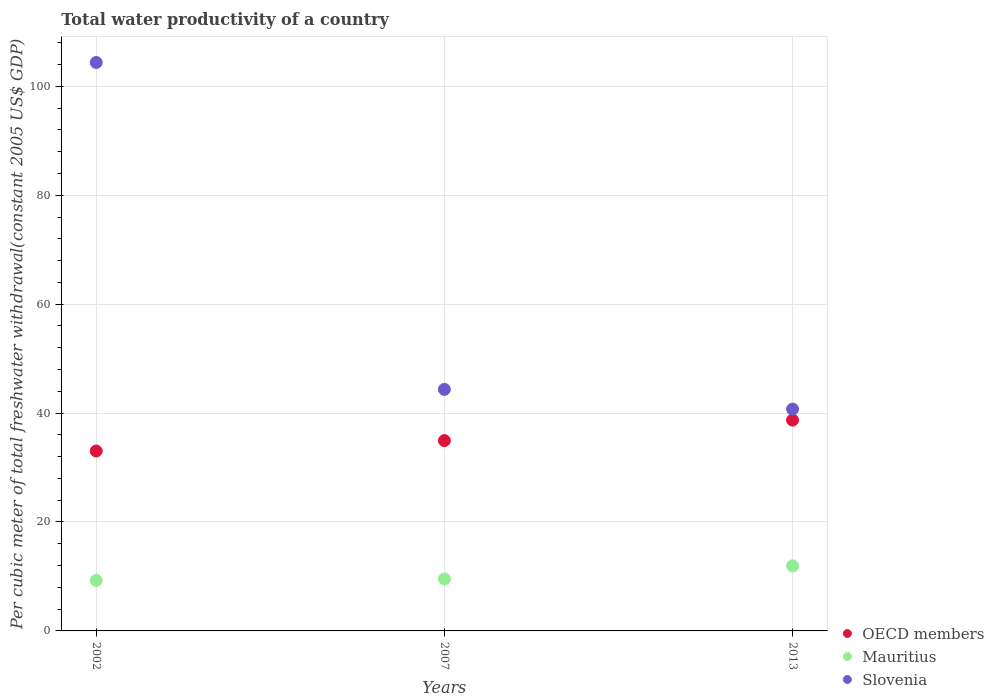What is the total water productivity in Slovenia in 2002?
Provide a short and direct response. 104.38. Across all years, what is the maximum total water productivity in Slovenia?
Offer a terse response. 104.38. Across all years, what is the minimum total water productivity in OECD members?
Your answer should be compact. 33.04. What is the total total water productivity in Slovenia in the graph?
Give a very brief answer. 189.45. What is the difference between the total water productivity in Mauritius in 2007 and that in 2013?
Make the answer very short. -2.41. What is the difference between the total water productivity in Mauritius in 2002 and the total water productivity in Slovenia in 2013?
Offer a very short reply. -31.44. What is the average total water productivity in Slovenia per year?
Your answer should be compact. 63.15. In the year 2013, what is the difference between the total water productivity in OECD members and total water productivity in Mauritius?
Provide a succinct answer. 26.76. In how many years, is the total water productivity in Mauritius greater than 28 US$?
Offer a terse response. 0. What is the ratio of the total water productivity in Slovenia in 2002 to that in 2013?
Ensure brevity in your answer.  2.56. Is the total water productivity in Slovenia in 2002 less than that in 2013?
Your answer should be very brief. No. What is the difference between the highest and the second highest total water productivity in Slovenia?
Offer a terse response. 60.02. What is the difference between the highest and the lowest total water productivity in OECD members?
Keep it short and to the point. 5.68. Is the sum of the total water productivity in Slovenia in 2002 and 2007 greater than the maximum total water productivity in Mauritius across all years?
Ensure brevity in your answer.  Yes. Is it the case that in every year, the sum of the total water productivity in Mauritius and total water productivity in OECD members  is greater than the total water productivity in Slovenia?
Offer a very short reply. No. Does the total water productivity in OECD members monotonically increase over the years?
Your response must be concise. Yes. Is the total water productivity in Slovenia strictly less than the total water productivity in Mauritius over the years?
Offer a terse response. No. Are the values on the major ticks of Y-axis written in scientific E-notation?
Provide a succinct answer. No. Does the graph contain grids?
Offer a very short reply. Yes. What is the title of the graph?
Give a very brief answer. Total water productivity of a country. Does "Monaco" appear as one of the legend labels in the graph?
Your answer should be very brief. No. What is the label or title of the X-axis?
Keep it short and to the point. Years. What is the label or title of the Y-axis?
Your response must be concise. Per cubic meter of total freshwater withdrawal(constant 2005 US$ GDP). What is the Per cubic meter of total freshwater withdrawal(constant 2005 US$ GDP) in OECD members in 2002?
Your response must be concise. 33.04. What is the Per cubic meter of total freshwater withdrawal(constant 2005 US$ GDP) in Mauritius in 2002?
Provide a succinct answer. 9.28. What is the Per cubic meter of total freshwater withdrawal(constant 2005 US$ GDP) in Slovenia in 2002?
Ensure brevity in your answer.  104.38. What is the Per cubic meter of total freshwater withdrawal(constant 2005 US$ GDP) of OECD members in 2007?
Your response must be concise. 34.94. What is the Per cubic meter of total freshwater withdrawal(constant 2005 US$ GDP) of Mauritius in 2007?
Provide a succinct answer. 9.54. What is the Per cubic meter of total freshwater withdrawal(constant 2005 US$ GDP) in Slovenia in 2007?
Offer a terse response. 44.35. What is the Per cubic meter of total freshwater withdrawal(constant 2005 US$ GDP) of OECD members in 2013?
Offer a very short reply. 38.71. What is the Per cubic meter of total freshwater withdrawal(constant 2005 US$ GDP) of Mauritius in 2013?
Provide a succinct answer. 11.95. What is the Per cubic meter of total freshwater withdrawal(constant 2005 US$ GDP) of Slovenia in 2013?
Give a very brief answer. 40.73. Across all years, what is the maximum Per cubic meter of total freshwater withdrawal(constant 2005 US$ GDP) in OECD members?
Your answer should be compact. 38.71. Across all years, what is the maximum Per cubic meter of total freshwater withdrawal(constant 2005 US$ GDP) in Mauritius?
Keep it short and to the point. 11.95. Across all years, what is the maximum Per cubic meter of total freshwater withdrawal(constant 2005 US$ GDP) of Slovenia?
Provide a short and direct response. 104.38. Across all years, what is the minimum Per cubic meter of total freshwater withdrawal(constant 2005 US$ GDP) of OECD members?
Your response must be concise. 33.04. Across all years, what is the minimum Per cubic meter of total freshwater withdrawal(constant 2005 US$ GDP) in Mauritius?
Your response must be concise. 9.28. Across all years, what is the minimum Per cubic meter of total freshwater withdrawal(constant 2005 US$ GDP) in Slovenia?
Keep it short and to the point. 40.73. What is the total Per cubic meter of total freshwater withdrawal(constant 2005 US$ GDP) in OECD members in the graph?
Your answer should be very brief. 106.69. What is the total Per cubic meter of total freshwater withdrawal(constant 2005 US$ GDP) in Mauritius in the graph?
Provide a short and direct response. 30.77. What is the total Per cubic meter of total freshwater withdrawal(constant 2005 US$ GDP) of Slovenia in the graph?
Ensure brevity in your answer.  189.45. What is the difference between the Per cubic meter of total freshwater withdrawal(constant 2005 US$ GDP) of OECD members in 2002 and that in 2007?
Ensure brevity in your answer.  -1.91. What is the difference between the Per cubic meter of total freshwater withdrawal(constant 2005 US$ GDP) in Mauritius in 2002 and that in 2007?
Offer a very short reply. -0.26. What is the difference between the Per cubic meter of total freshwater withdrawal(constant 2005 US$ GDP) in Slovenia in 2002 and that in 2007?
Your answer should be very brief. 60.02. What is the difference between the Per cubic meter of total freshwater withdrawal(constant 2005 US$ GDP) in OECD members in 2002 and that in 2013?
Ensure brevity in your answer.  -5.68. What is the difference between the Per cubic meter of total freshwater withdrawal(constant 2005 US$ GDP) in Mauritius in 2002 and that in 2013?
Give a very brief answer. -2.66. What is the difference between the Per cubic meter of total freshwater withdrawal(constant 2005 US$ GDP) in Slovenia in 2002 and that in 2013?
Offer a terse response. 63.65. What is the difference between the Per cubic meter of total freshwater withdrawal(constant 2005 US$ GDP) of OECD members in 2007 and that in 2013?
Give a very brief answer. -3.77. What is the difference between the Per cubic meter of total freshwater withdrawal(constant 2005 US$ GDP) in Mauritius in 2007 and that in 2013?
Offer a terse response. -2.41. What is the difference between the Per cubic meter of total freshwater withdrawal(constant 2005 US$ GDP) of Slovenia in 2007 and that in 2013?
Provide a short and direct response. 3.62. What is the difference between the Per cubic meter of total freshwater withdrawal(constant 2005 US$ GDP) of OECD members in 2002 and the Per cubic meter of total freshwater withdrawal(constant 2005 US$ GDP) of Mauritius in 2007?
Keep it short and to the point. 23.5. What is the difference between the Per cubic meter of total freshwater withdrawal(constant 2005 US$ GDP) of OECD members in 2002 and the Per cubic meter of total freshwater withdrawal(constant 2005 US$ GDP) of Slovenia in 2007?
Keep it short and to the point. -11.31. What is the difference between the Per cubic meter of total freshwater withdrawal(constant 2005 US$ GDP) in Mauritius in 2002 and the Per cubic meter of total freshwater withdrawal(constant 2005 US$ GDP) in Slovenia in 2007?
Provide a succinct answer. -35.07. What is the difference between the Per cubic meter of total freshwater withdrawal(constant 2005 US$ GDP) in OECD members in 2002 and the Per cubic meter of total freshwater withdrawal(constant 2005 US$ GDP) in Mauritius in 2013?
Make the answer very short. 21.09. What is the difference between the Per cubic meter of total freshwater withdrawal(constant 2005 US$ GDP) of OECD members in 2002 and the Per cubic meter of total freshwater withdrawal(constant 2005 US$ GDP) of Slovenia in 2013?
Make the answer very short. -7.69. What is the difference between the Per cubic meter of total freshwater withdrawal(constant 2005 US$ GDP) in Mauritius in 2002 and the Per cubic meter of total freshwater withdrawal(constant 2005 US$ GDP) in Slovenia in 2013?
Ensure brevity in your answer.  -31.44. What is the difference between the Per cubic meter of total freshwater withdrawal(constant 2005 US$ GDP) in OECD members in 2007 and the Per cubic meter of total freshwater withdrawal(constant 2005 US$ GDP) in Mauritius in 2013?
Offer a very short reply. 23. What is the difference between the Per cubic meter of total freshwater withdrawal(constant 2005 US$ GDP) in OECD members in 2007 and the Per cubic meter of total freshwater withdrawal(constant 2005 US$ GDP) in Slovenia in 2013?
Your response must be concise. -5.78. What is the difference between the Per cubic meter of total freshwater withdrawal(constant 2005 US$ GDP) in Mauritius in 2007 and the Per cubic meter of total freshwater withdrawal(constant 2005 US$ GDP) in Slovenia in 2013?
Offer a terse response. -31.19. What is the average Per cubic meter of total freshwater withdrawal(constant 2005 US$ GDP) of OECD members per year?
Give a very brief answer. 35.56. What is the average Per cubic meter of total freshwater withdrawal(constant 2005 US$ GDP) in Mauritius per year?
Give a very brief answer. 10.26. What is the average Per cubic meter of total freshwater withdrawal(constant 2005 US$ GDP) in Slovenia per year?
Your answer should be compact. 63.15. In the year 2002, what is the difference between the Per cubic meter of total freshwater withdrawal(constant 2005 US$ GDP) of OECD members and Per cubic meter of total freshwater withdrawal(constant 2005 US$ GDP) of Mauritius?
Offer a very short reply. 23.75. In the year 2002, what is the difference between the Per cubic meter of total freshwater withdrawal(constant 2005 US$ GDP) in OECD members and Per cubic meter of total freshwater withdrawal(constant 2005 US$ GDP) in Slovenia?
Offer a terse response. -71.34. In the year 2002, what is the difference between the Per cubic meter of total freshwater withdrawal(constant 2005 US$ GDP) of Mauritius and Per cubic meter of total freshwater withdrawal(constant 2005 US$ GDP) of Slovenia?
Offer a very short reply. -95.09. In the year 2007, what is the difference between the Per cubic meter of total freshwater withdrawal(constant 2005 US$ GDP) of OECD members and Per cubic meter of total freshwater withdrawal(constant 2005 US$ GDP) of Mauritius?
Provide a short and direct response. 25.4. In the year 2007, what is the difference between the Per cubic meter of total freshwater withdrawal(constant 2005 US$ GDP) in OECD members and Per cubic meter of total freshwater withdrawal(constant 2005 US$ GDP) in Slovenia?
Ensure brevity in your answer.  -9.41. In the year 2007, what is the difference between the Per cubic meter of total freshwater withdrawal(constant 2005 US$ GDP) of Mauritius and Per cubic meter of total freshwater withdrawal(constant 2005 US$ GDP) of Slovenia?
Keep it short and to the point. -34.81. In the year 2013, what is the difference between the Per cubic meter of total freshwater withdrawal(constant 2005 US$ GDP) of OECD members and Per cubic meter of total freshwater withdrawal(constant 2005 US$ GDP) of Mauritius?
Provide a short and direct response. 26.76. In the year 2013, what is the difference between the Per cubic meter of total freshwater withdrawal(constant 2005 US$ GDP) in OECD members and Per cubic meter of total freshwater withdrawal(constant 2005 US$ GDP) in Slovenia?
Your answer should be compact. -2.01. In the year 2013, what is the difference between the Per cubic meter of total freshwater withdrawal(constant 2005 US$ GDP) in Mauritius and Per cubic meter of total freshwater withdrawal(constant 2005 US$ GDP) in Slovenia?
Provide a short and direct response. -28.78. What is the ratio of the Per cubic meter of total freshwater withdrawal(constant 2005 US$ GDP) in OECD members in 2002 to that in 2007?
Give a very brief answer. 0.95. What is the ratio of the Per cubic meter of total freshwater withdrawal(constant 2005 US$ GDP) in Slovenia in 2002 to that in 2007?
Your response must be concise. 2.35. What is the ratio of the Per cubic meter of total freshwater withdrawal(constant 2005 US$ GDP) of OECD members in 2002 to that in 2013?
Offer a terse response. 0.85. What is the ratio of the Per cubic meter of total freshwater withdrawal(constant 2005 US$ GDP) of Mauritius in 2002 to that in 2013?
Offer a very short reply. 0.78. What is the ratio of the Per cubic meter of total freshwater withdrawal(constant 2005 US$ GDP) of Slovenia in 2002 to that in 2013?
Your answer should be compact. 2.56. What is the ratio of the Per cubic meter of total freshwater withdrawal(constant 2005 US$ GDP) of OECD members in 2007 to that in 2013?
Offer a very short reply. 0.9. What is the ratio of the Per cubic meter of total freshwater withdrawal(constant 2005 US$ GDP) in Mauritius in 2007 to that in 2013?
Keep it short and to the point. 0.8. What is the ratio of the Per cubic meter of total freshwater withdrawal(constant 2005 US$ GDP) of Slovenia in 2007 to that in 2013?
Your answer should be compact. 1.09. What is the difference between the highest and the second highest Per cubic meter of total freshwater withdrawal(constant 2005 US$ GDP) in OECD members?
Provide a short and direct response. 3.77. What is the difference between the highest and the second highest Per cubic meter of total freshwater withdrawal(constant 2005 US$ GDP) of Mauritius?
Your answer should be very brief. 2.41. What is the difference between the highest and the second highest Per cubic meter of total freshwater withdrawal(constant 2005 US$ GDP) in Slovenia?
Provide a short and direct response. 60.02. What is the difference between the highest and the lowest Per cubic meter of total freshwater withdrawal(constant 2005 US$ GDP) in OECD members?
Your response must be concise. 5.68. What is the difference between the highest and the lowest Per cubic meter of total freshwater withdrawal(constant 2005 US$ GDP) in Mauritius?
Offer a very short reply. 2.66. What is the difference between the highest and the lowest Per cubic meter of total freshwater withdrawal(constant 2005 US$ GDP) in Slovenia?
Offer a terse response. 63.65. 